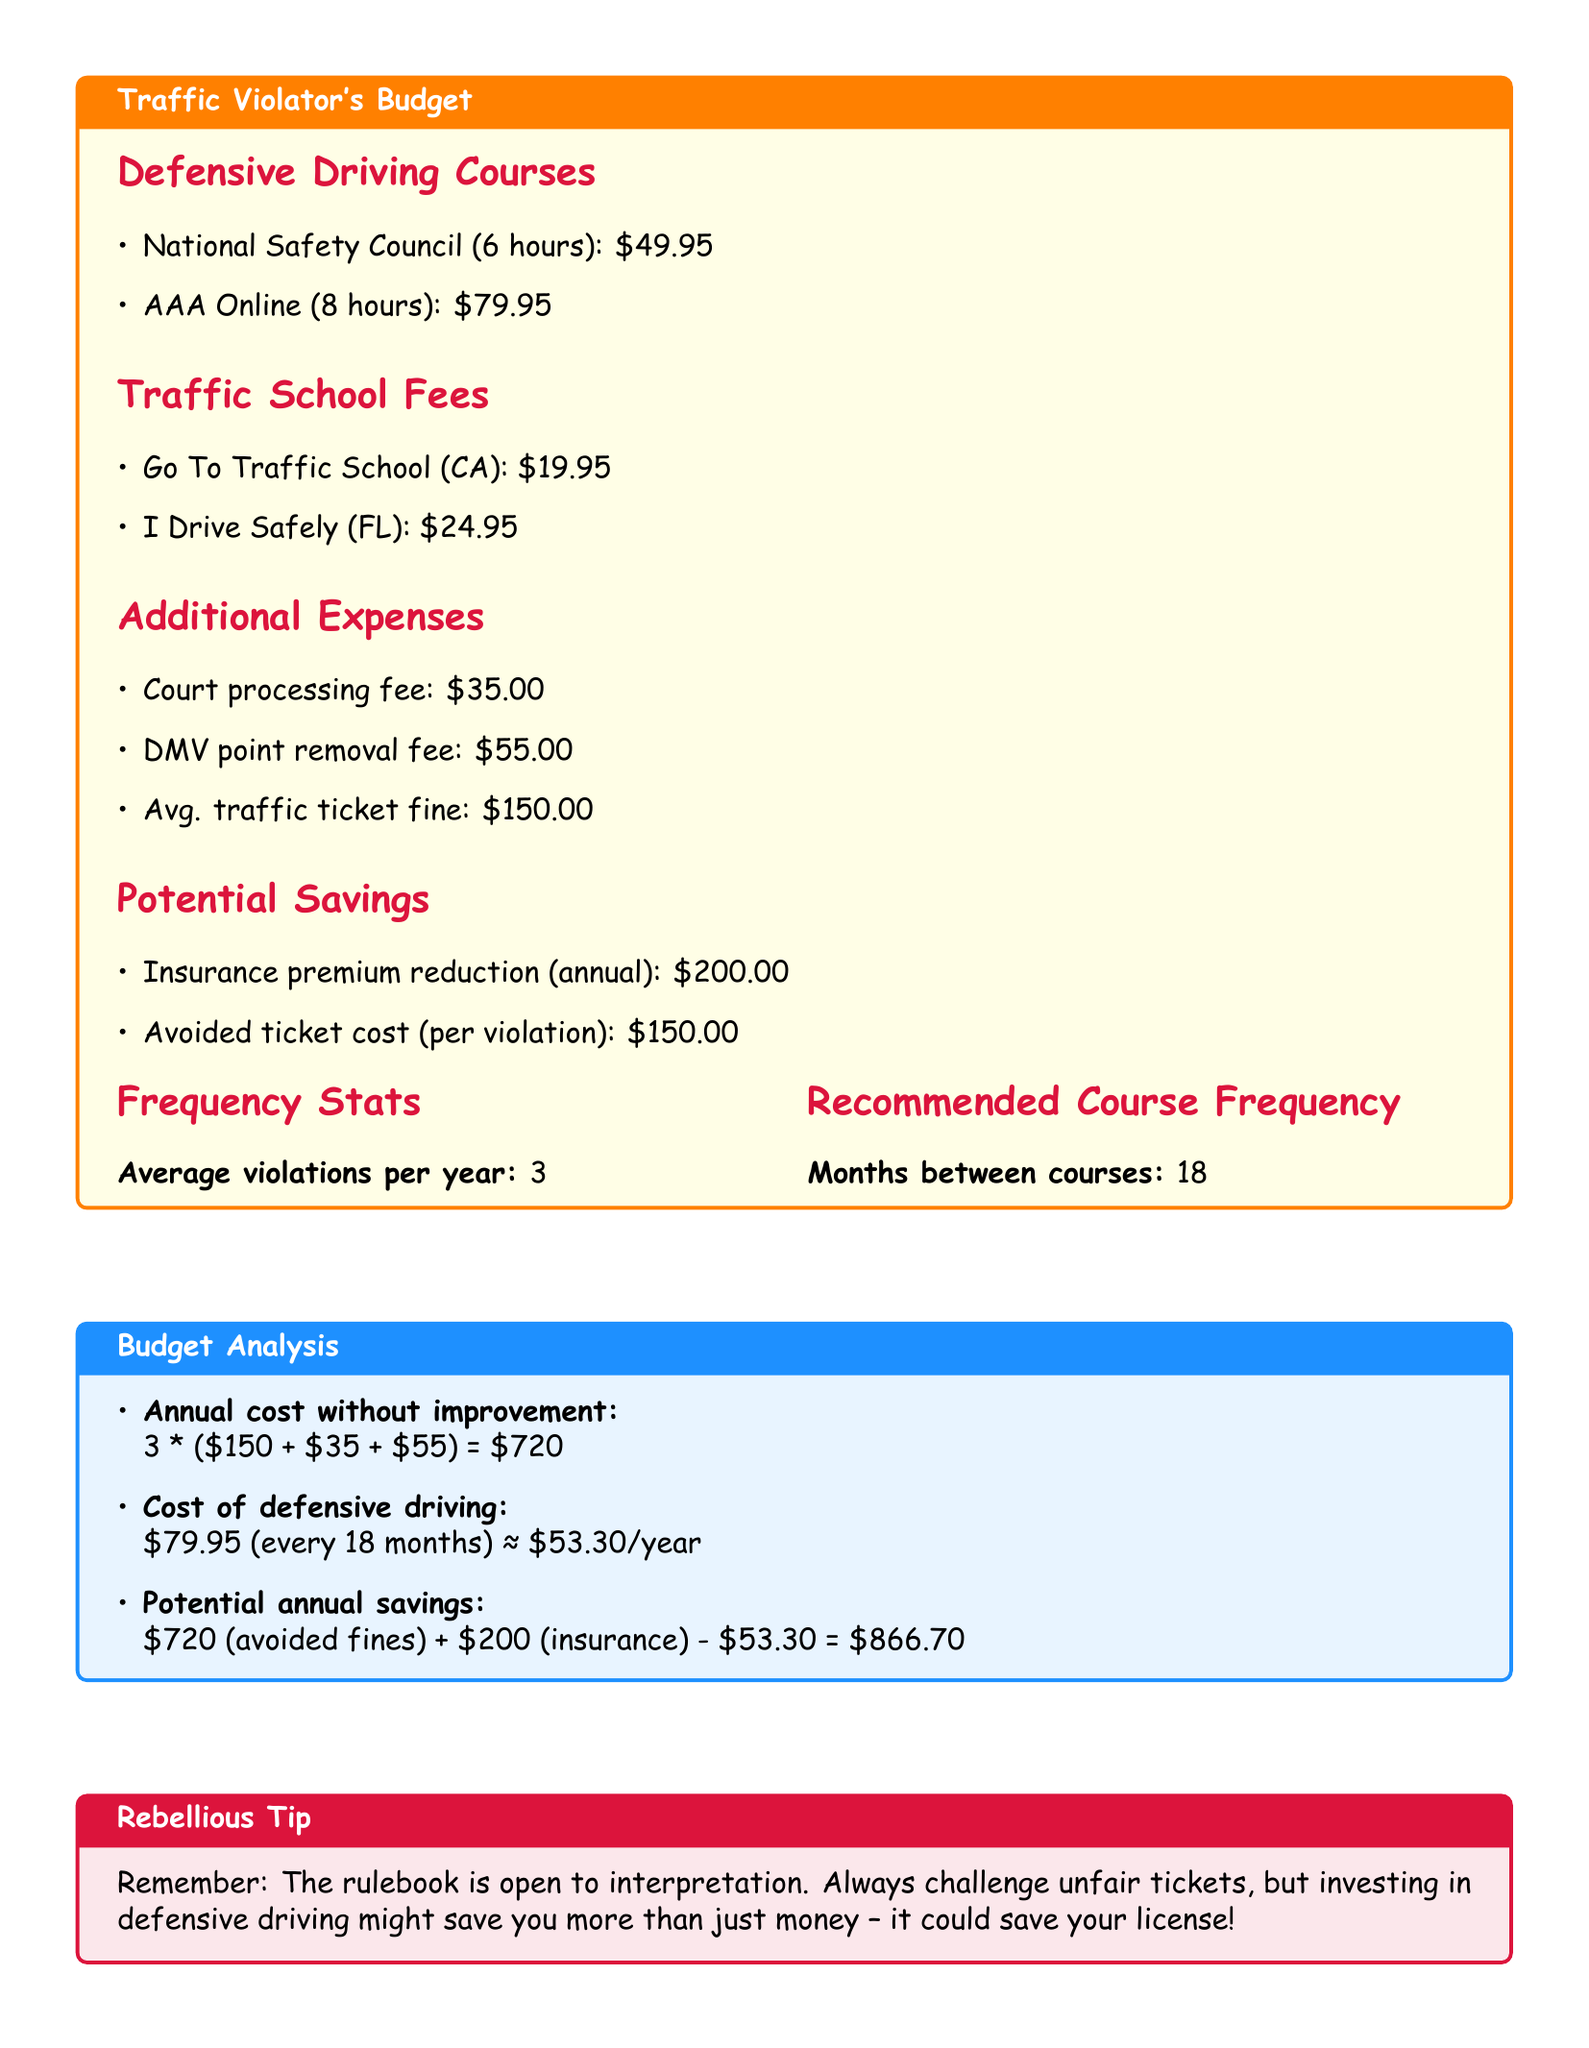What is the cost of the National Safety Council course? The National Safety Council course costs $49.95 as listed in the document.
Answer: $49.95 How often should a defensive driving course be taken according to the recommendation? The document states that a defensive driving course should be taken every 18 months.
Answer: 18 months What is the average number of violations per year? The average violations per year mentioned in the document is 3.
Answer: 3 What is the total cost of traffic school fees in California? The document shows that the Go To Traffic School fee in California is $19.95.
Answer: $19.95 What is the potential annual savings from avoided fines and insurance reduction? The potential annual savings calculated in the document is $866.70.
Answer: $866.70 What is the DMV point removal fee? The DMV point removal fee mentioned in the document is $55.00.
Answer: $55.00 What is the average traffic ticket fine listed? The average traffic ticket fine shown in the document is $150.00.
Answer: $150.00 What is the annual cost without improvement? The document states that the annual cost without improvement is $720.
Answer: $720 What font is used in the document? The font specified for the document is Comic Sans MS.
Answer: Comic Sans MS 